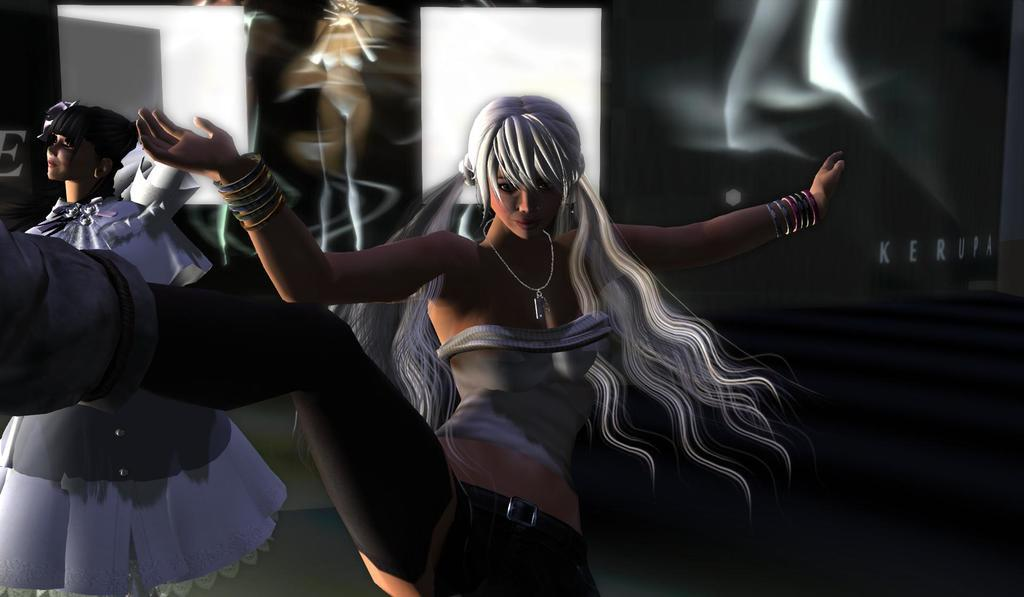How many people are in the image? There are two persons in the image. Where are the two persons located in the image? The two persons are in the center of the image. What can be seen in the background of the image? There are objects in the background of the image. What type of creature is increasing in population in the image? There is no creature present in the image, and no information about population changes is provided. 